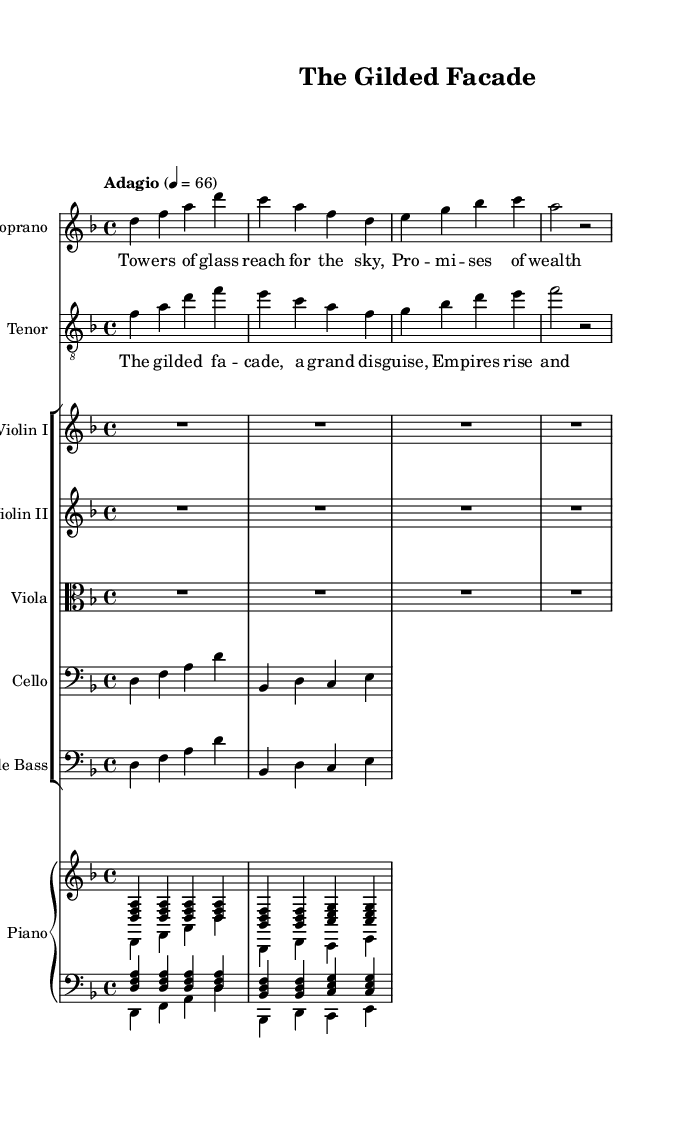What is the key signature of this music? The key signature is indicated at the beginning of the sheet music, showing two flats. This identifies the key of D minor, which has one flat (C) and its relative major, F major, also has one flat.
Answer: D minor What is the time signature of this music? The time signature is found at the beginning of the sheet music, indicated by the numbers 4/4. This means there are four beats in each measure, and the quarter note gets one beat.
Answer: 4/4 What is the tempo marking for this piece? The tempo marking appears after the time signature, stating "Adagio" and suggesting a slow tempo of 66 beats per minute. This guides the player on how fast or slow to perform the piece.
Answer: Adagio How many voices are present in this score? By examining the score, we see that there are two main vocal parts labeled as Soprano and Tenor, each with corresponding lyrics. Additionally, there is also an ensemble of strings and a piano accompaniment.
Answer: Two What do the lyrics of the Soprano part symbolize? The lyrics provided in the Soprano part highlight the grandeur and fleeting nature of wealth in real estate empires, as described in lines such as "Towers of glass reach for the sky," indicating ambition and aspirations.
Answer: Ambition How do the lyrics of the Chorus relate to the theme of the opera? The lyrics in the Chorus express the cyclical nature of real estate empires rising and falling, which mirrors societal trends and human folly, encapsulating the core theme of the opera about the ephemeral nature of material wealth.
Answer: Ephemeral nature Which instruments are designated to play the accompaniment? The score indicates a configuration for strings and piano as part of the accompaniment. Specifically, it includes two violins, a viola, a cello, a double bass, and a piano, creating a rich ensemble.
Answer: Strings and piano 